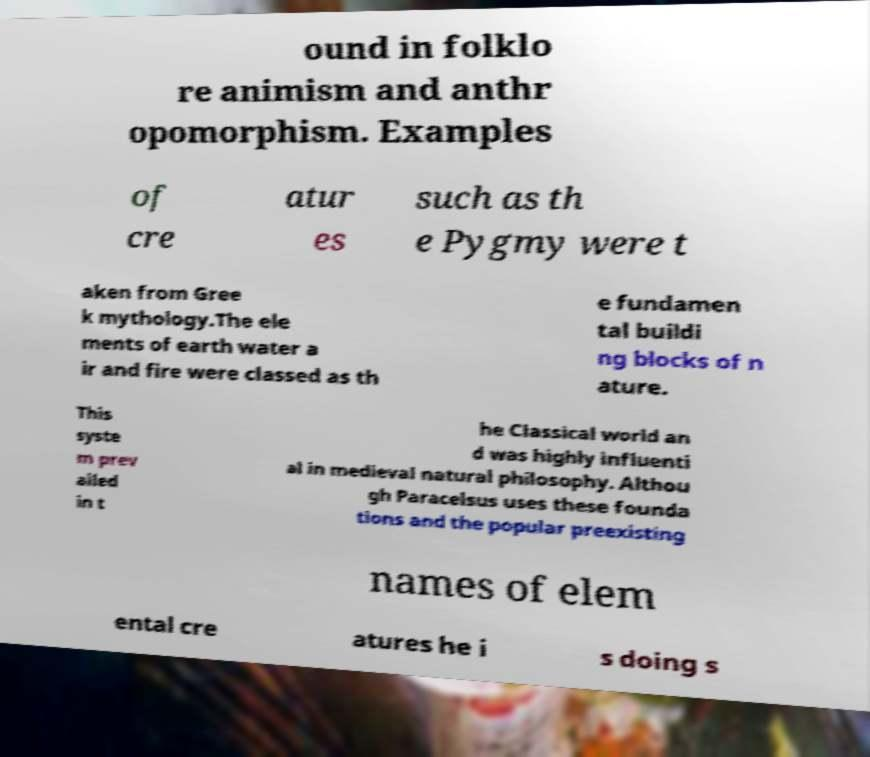Could you assist in decoding the text presented in this image and type it out clearly? ound in folklo re animism and anthr opomorphism. Examples of cre atur es such as th e Pygmy were t aken from Gree k mythology.The ele ments of earth water a ir and fire were classed as th e fundamen tal buildi ng blocks of n ature. This syste m prev ailed in t he Classical world an d was highly influenti al in medieval natural philosophy. Althou gh Paracelsus uses these founda tions and the popular preexisting names of elem ental cre atures he i s doing s 